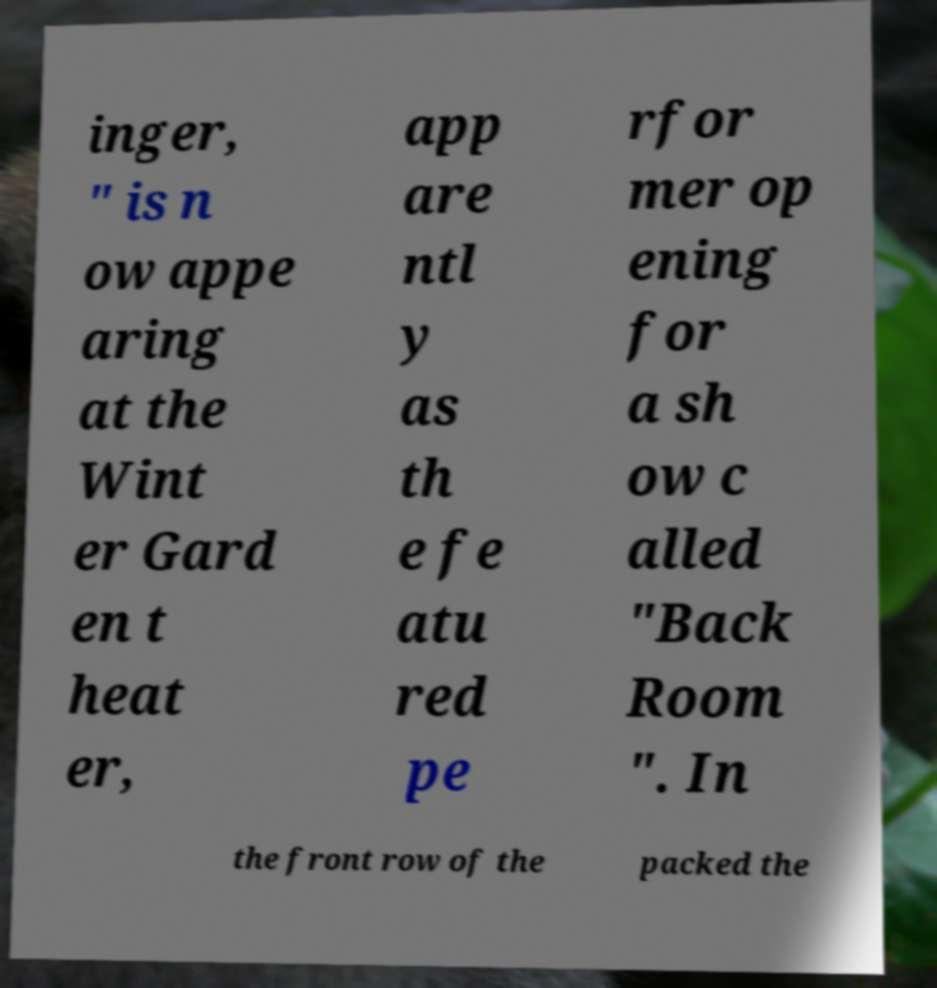Could you extract and type out the text from this image? inger, " is n ow appe aring at the Wint er Gard en t heat er, app are ntl y as th e fe atu red pe rfor mer op ening for a sh ow c alled "Back Room ". In the front row of the packed the 